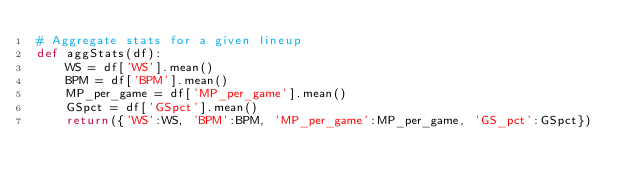Convert code to text. <code><loc_0><loc_0><loc_500><loc_500><_Python_># Aggregate stats for a given lineup
def aggStats(df):
    WS = df['WS'].mean()
    BPM = df['BPM'].mean()
    MP_per_game = df['MP_per_game'].mean()
    GSpct = df['GSpct'].mean()  
    return({'WS':WS, 'BPM':BPM, 'MP_per_game':MP_per_game, 'GS_pct':GSpct})</code> 